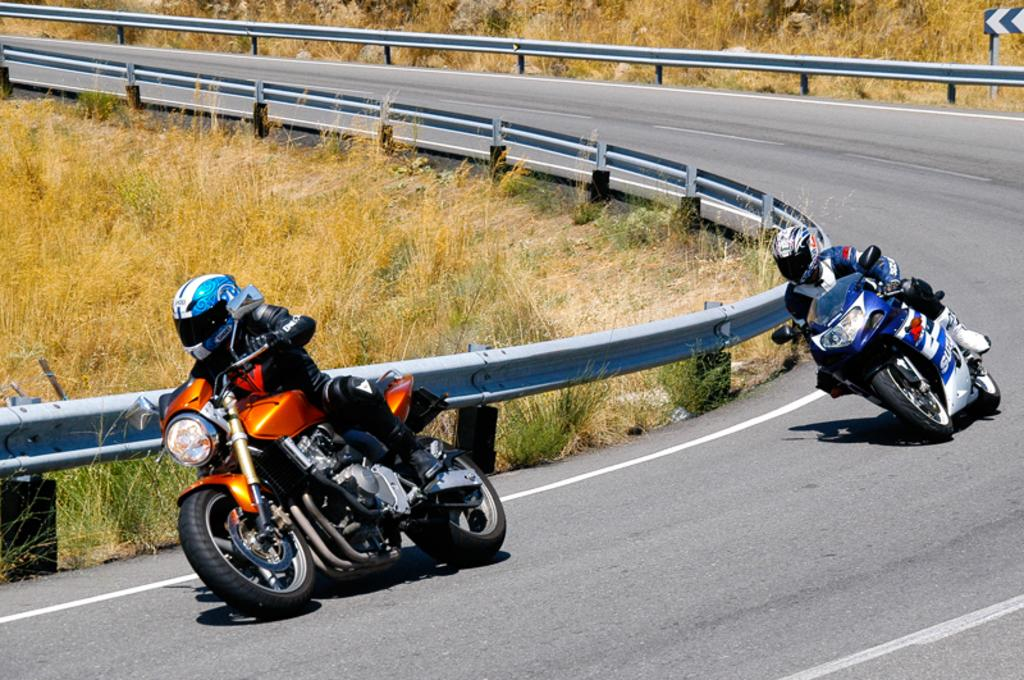What are the persons in the image doing? The persons in the image are riding a motorcycle. Where is the motorcycle located? The motorcycle is on the road. What can be seen at the side of the road? There is a railing, a board, and grass at the side of the road. How many pigs are lifting the motorcycle in the image? There are no pigs present in the image, and the motorcycle is not being lifted. What is the color of the neck of the person riding the motorcycle? The provided facts do not mention the color of the person's neck, and it cannot be determined from the image. 